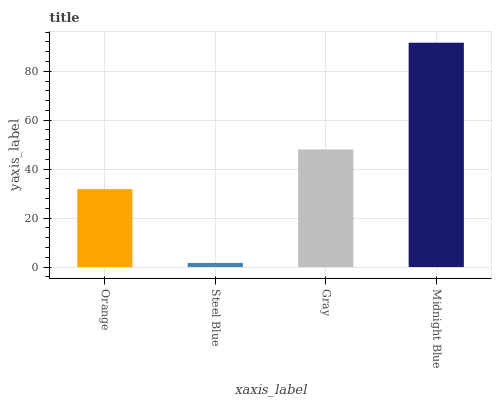Is Steel Blue the minimum?
Answer yes or no. Yes. Is Midnight Blue the maximum?
Answer yes or no. Yes. Is Gray the minimum?
Answer yes or no. No. Is Gray the maximum?
Answer yes or no. No. Is Gray greater than Steel Blue?
Answer yes or no. Yes. Is Steel Blue less than Gray?
Answer yes or no. Yes. Is Steel Blue greater than Gray?
Answer yes or no. No. Is Gray less than Steel Blue?
Answer yes or no. No. Is Gray the high median?
Answer yes or no. Yes. Is Orange the low median?
Answer yes or no. Yes. Is Steel Blue the high median?
Answer yes or no. No. Is Gray the low median?
Answer yes or no. No. 